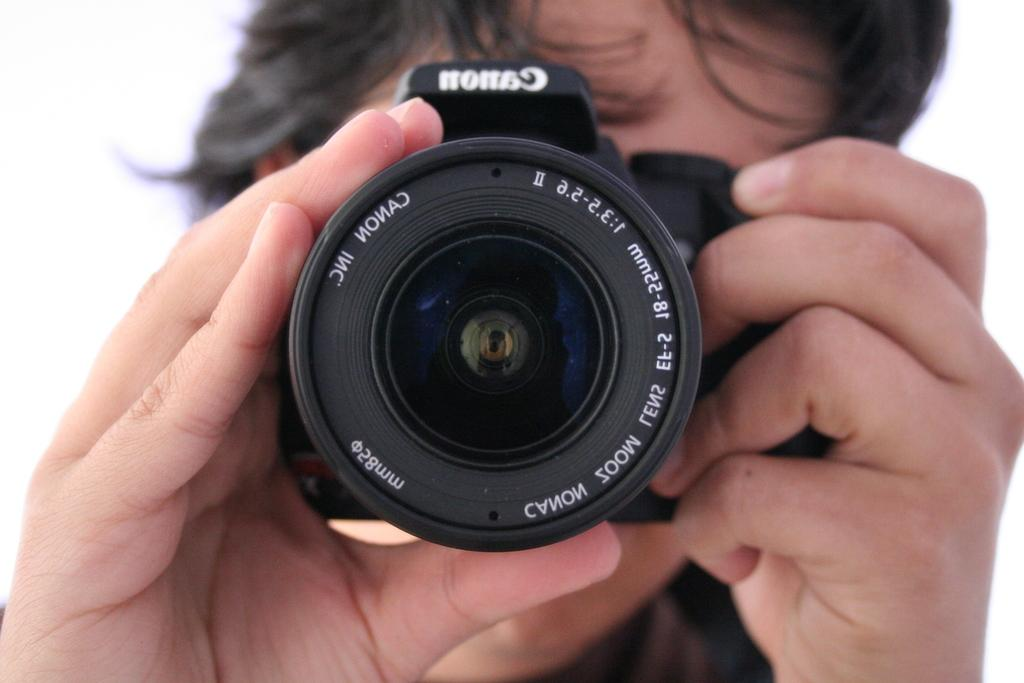<image>
Render a clear and concise summary of the photo. A person holding a Canon Inc. camera pointing the lens. 